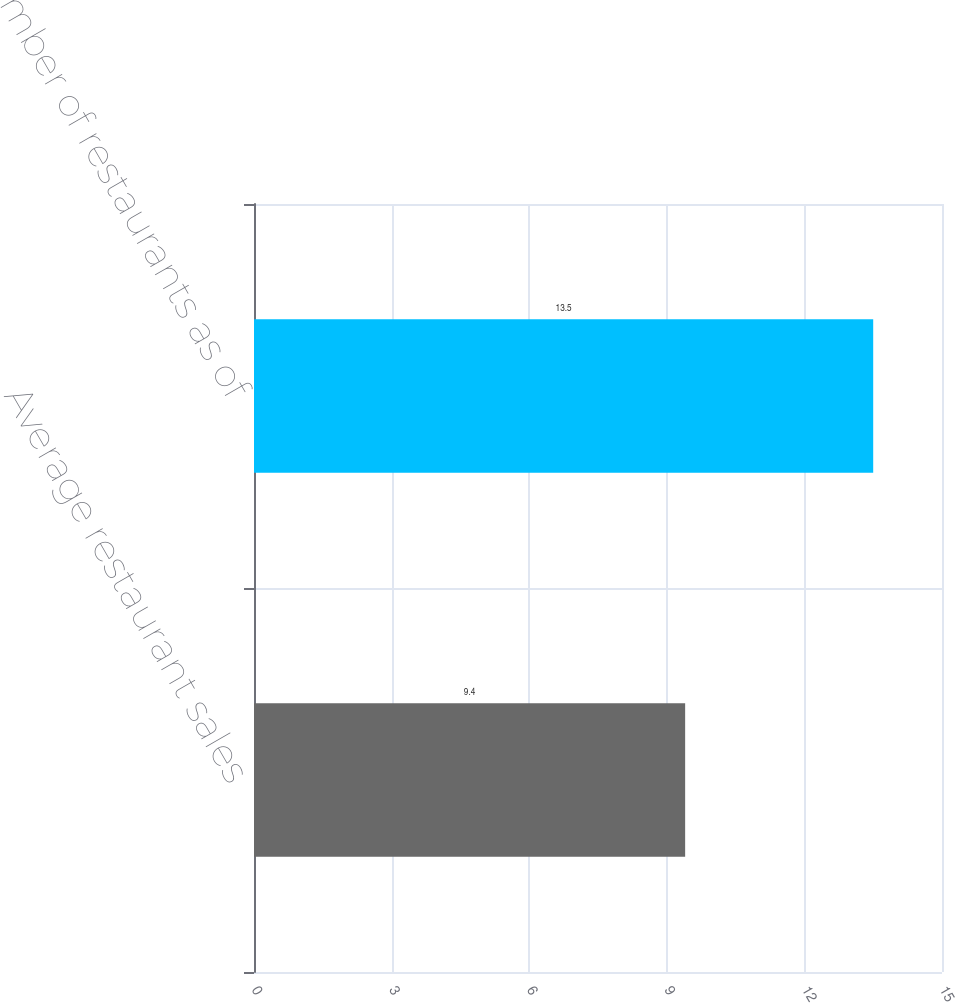Convert chart to OTSL. <chart><loc_0><loc_0><loc_500><loc_500><bar_chart><fcel>Average restaurant sales<fcel>Number of restaurants as of<nl><fcel>9.4<fcel>13.5<nl></chart> 